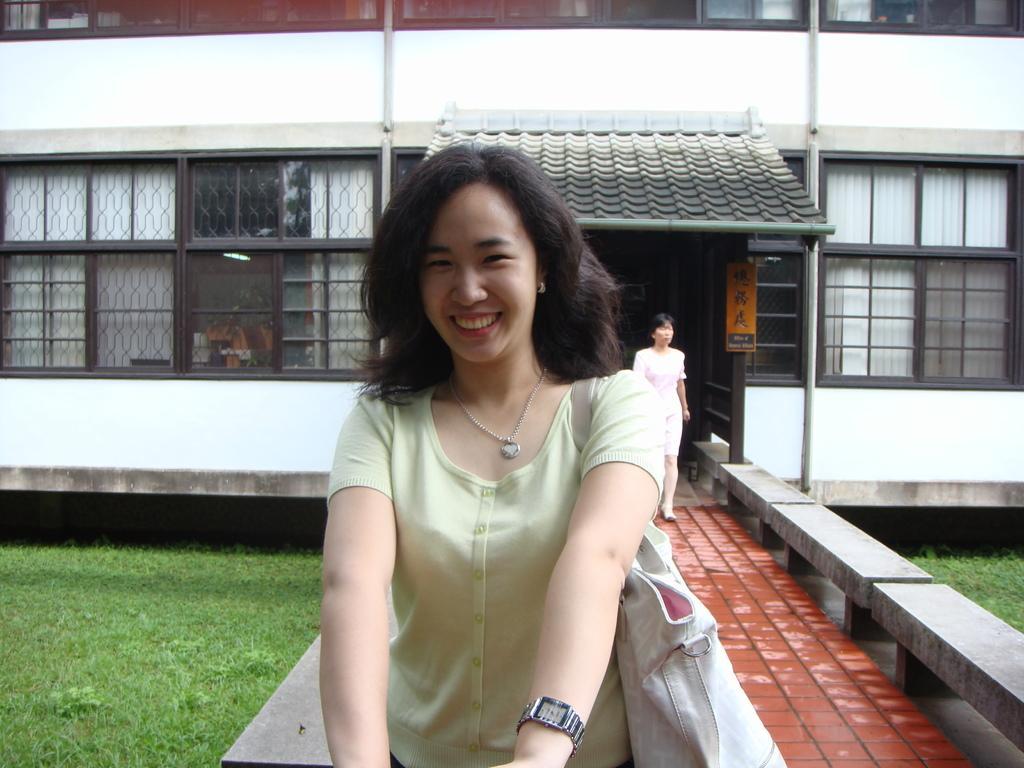Please provide a concise description of this image. In this image we can see a woman smiling and posing for a photo and we can see a building in the background and there is a woman walking on the floor and we can see the grass on the ground. 